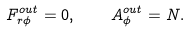<formula> <loc_0><loc_0><loc_500><loc_500>F _ { r \phi } ^ { o u t } = 0 , \quad A _ { \phi } ^ { o u t } = N .</formula> 